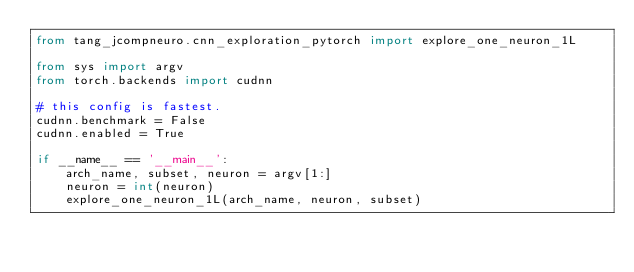Convert code to text. <code><loc_0><loc_0><loc_500><loc_500><_Python_>from tang_jcompneuro.cnn_exploration_pytorch import explore_one_neuron_1L

from sys import argv
from torch.backends import cudnn

# this config is fastest.
cudnn.benchmark = False
cudnn.enabled = True

if __name__ == '__main__':
    arch_name, subset, neuron = argv[1:]
    neuron = int(neuron)
    explore_one_neuron_1L(arch_name, neuron, subset)
</code> 